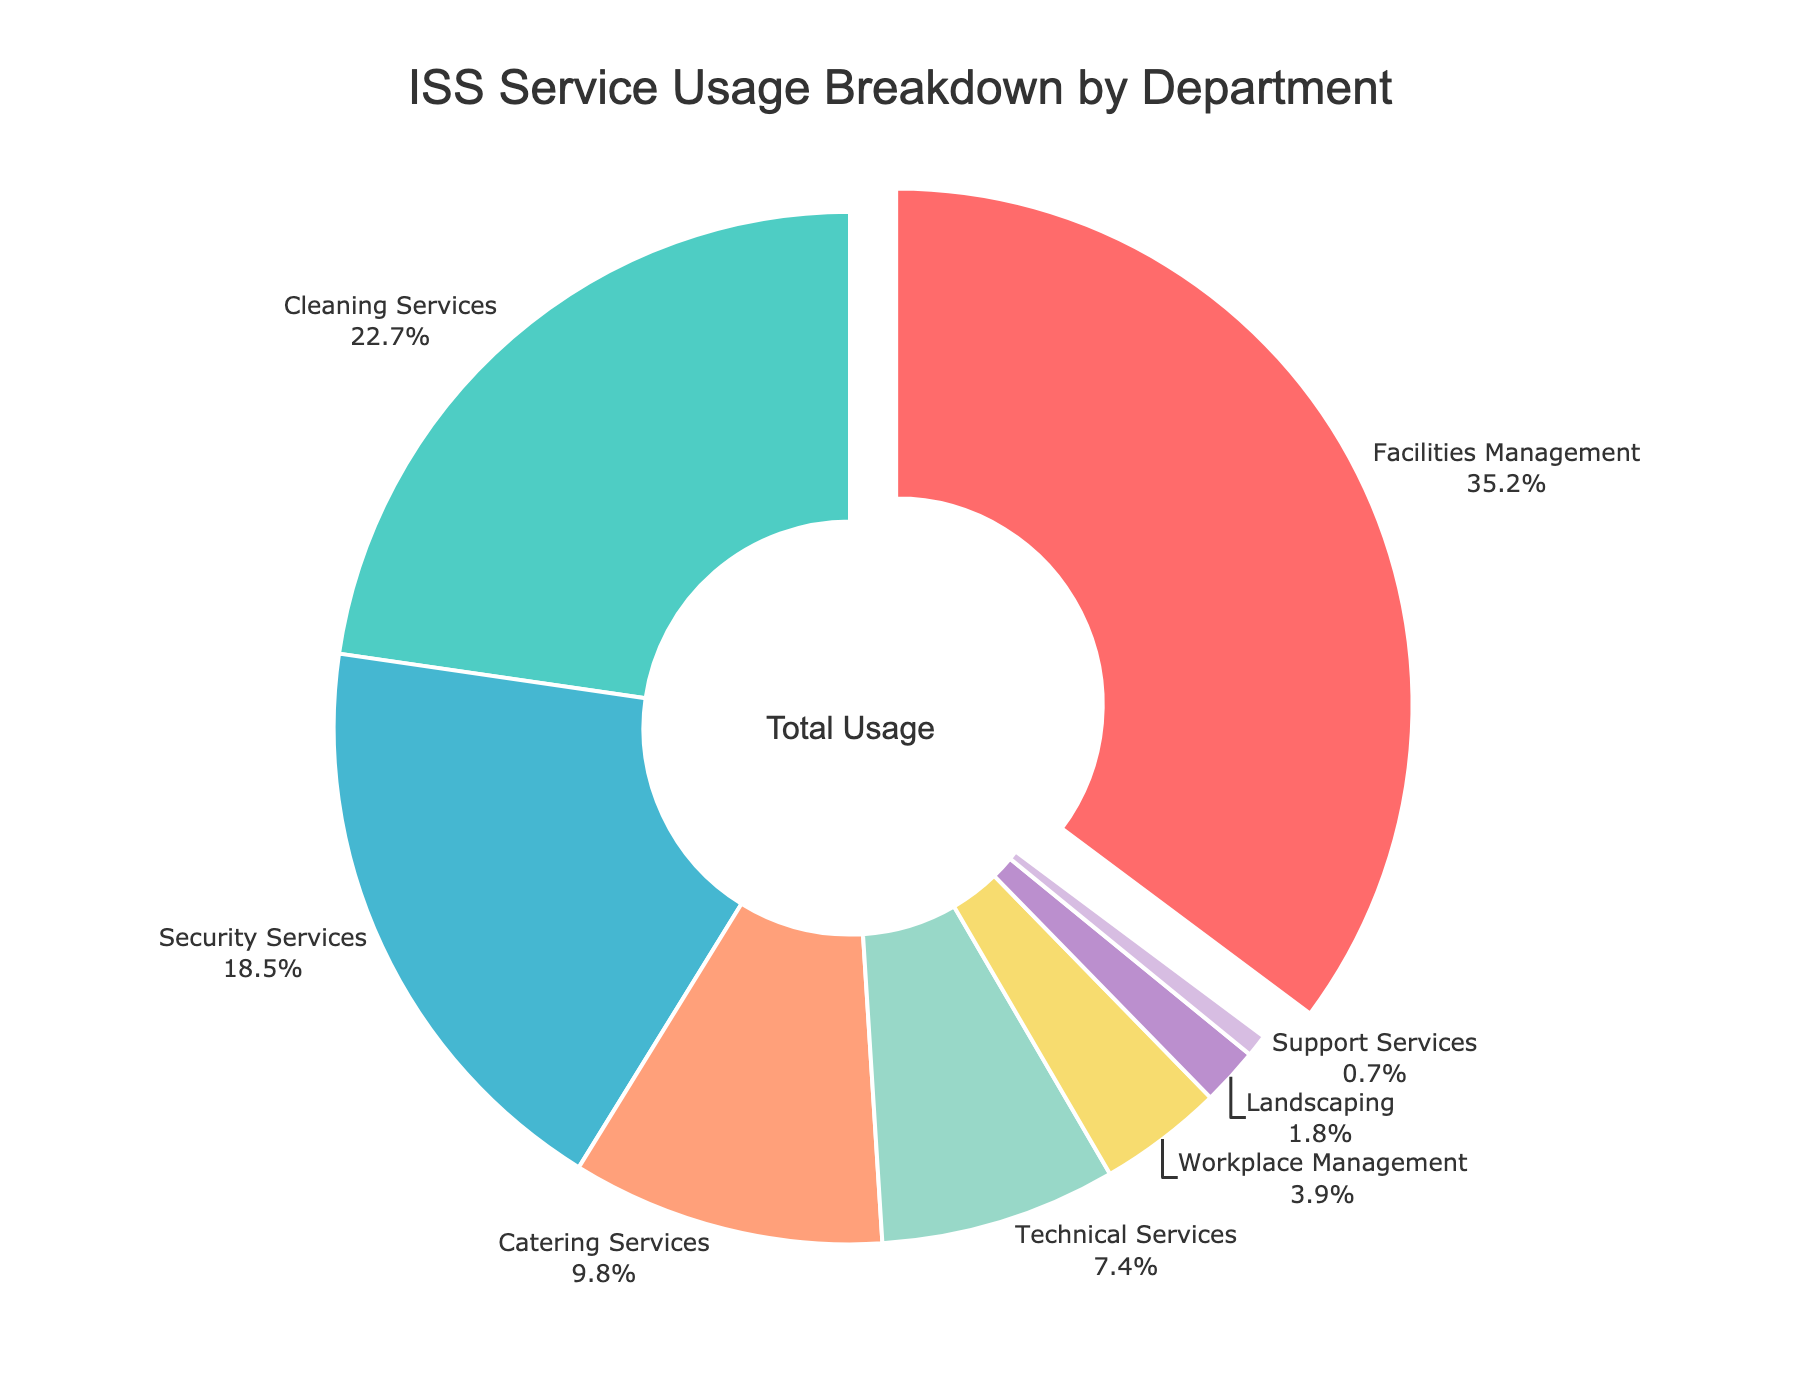What percentage of the total usage is accounted for by the top three departments? Sum the percentages of the top three departments: Facilities Management (35.2%), Cleaning Services (22.7%), and Security Services (18.5%). So, 35.2 + 22.7 + 18.5 = 76.4.
Answer: 76.4% Which department has the lowest usage percentage and what is that percentage? Identify the department with the smallest percentage in the pie chart, which is Support Services with 0.7%.
Answer: Support Services, 0.7% How much more is the usage percentage of Facilities Management compared to Technical Services? Subtract the percentage of Technical Services from that of Facilities Management: 35.2% - 7.4% = 27.8%.
Answer: 27.8% What is the combined percentage of Catering Services and Workplace Management? Add the percentages of Catering Services (9.8%) and Workplace Management (3.9%): 9.8 + 3.9 = 13.7.
Answer: 13.7% Which two departments combined account for approximately 41.2% of the total usage? Find two departments whose percentages add up to 41.2%. Facilities Management (35.2%) and Landscaping (1.8%) together account for 35.2 + 6.0 = 41.2.
Answer: Facilities Management and Technical Services What is the difference in usage percentage between Cleaning Services and Catering Services? Subtract the percentage of Catering Services from Cleaning Services: 22.7% - 9.8% = 12.9%.
Answer: 12.9% Which department appears with the largest segment of the pie chart and what is its unique visual feature? Identify the department with the largest segment, Facilities Management (35.2%), which is visually separated (pulled out slightly).
Answer: Facilities Management, largest segment and visually pulled out What is the total usage percentage for departments having less than 8% usage each? Sum the percentages for Technical Services (7.4%), Workplace Management (3.9%), Landscaping (1.8%), and Support Services (0.7%): 7.4 + 3.9 + 1.8 + 0.7 = 13.8%.
Answer: 13.8% How does the usage percentage of Security Services compare to that of Cleaning Services? Compare the percentages: Security Services (18.5%) is lower than Cleaning Services (22.7%).
Answer: Lower What’s the total usage percentage of departments excluding Facilities Management and Cleaning Services? Subtract the sum of Facilities Management and Cleaning Services from 100%: 100 - (35.2 + 22.7) = 42.1%.
Answer: 42.1% 